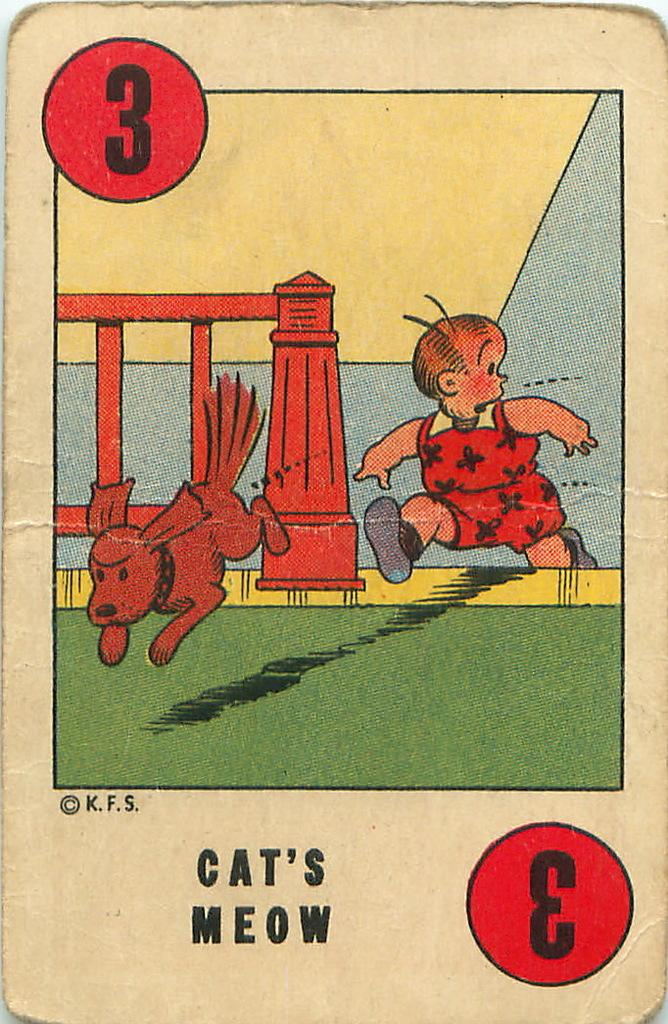What is depicted on the card in the image? The card has a drawing of a boy and a dog. What type of object is the card made of? The card is made of paper or a similar material. What can be seen in the background of the image? There is a wooden railing in the background of the image. How does the soap on the card kick the ball in the image? There is no soap or ball present in the image; the card only features drawings of a boy and a dog. 